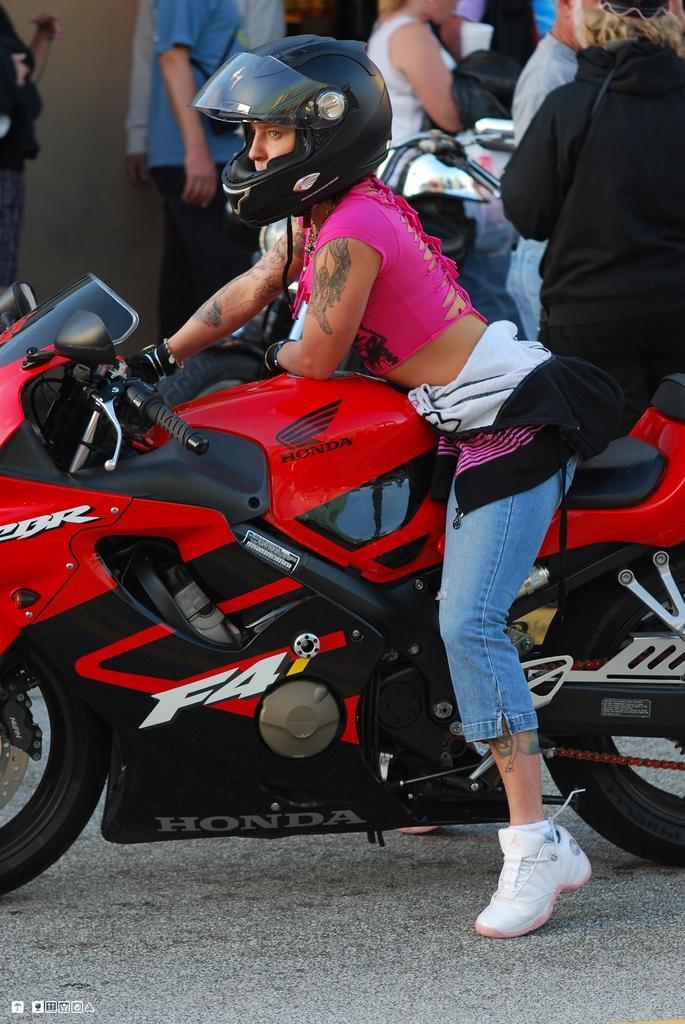Can you describe this image briefly? In the background we can see the people. In this picture we can see a woman wearing a helmet and she is sitting on a motorbike. At the bottom portion of the picture we can see the road and watermark. 